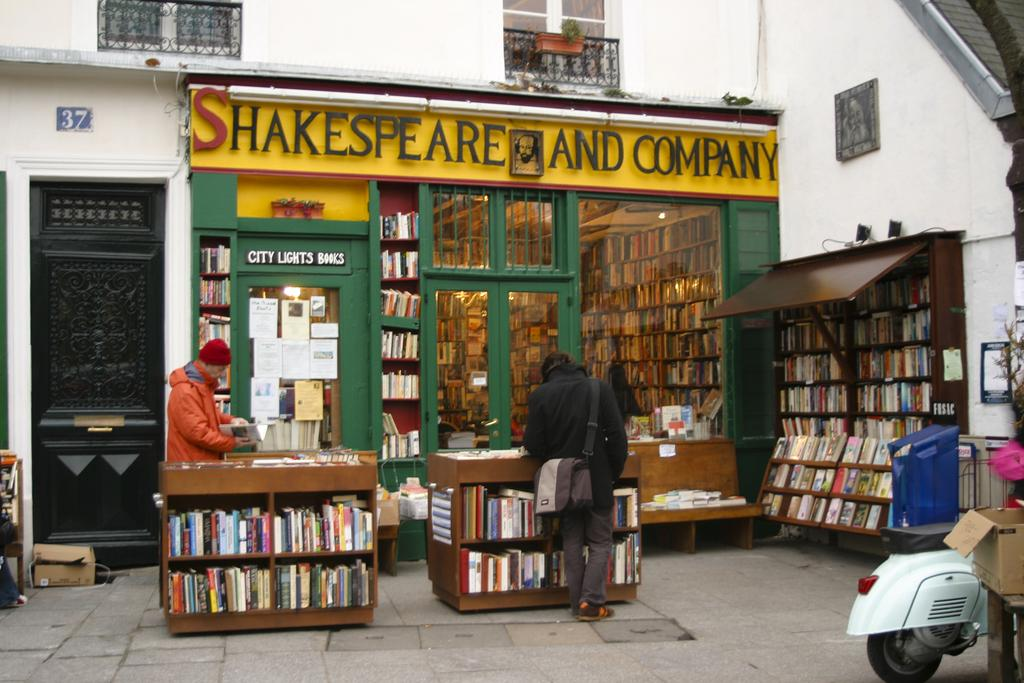<image>
Provide a brief description of the given image. The outside of a bookstore called Shakespeare and Company 